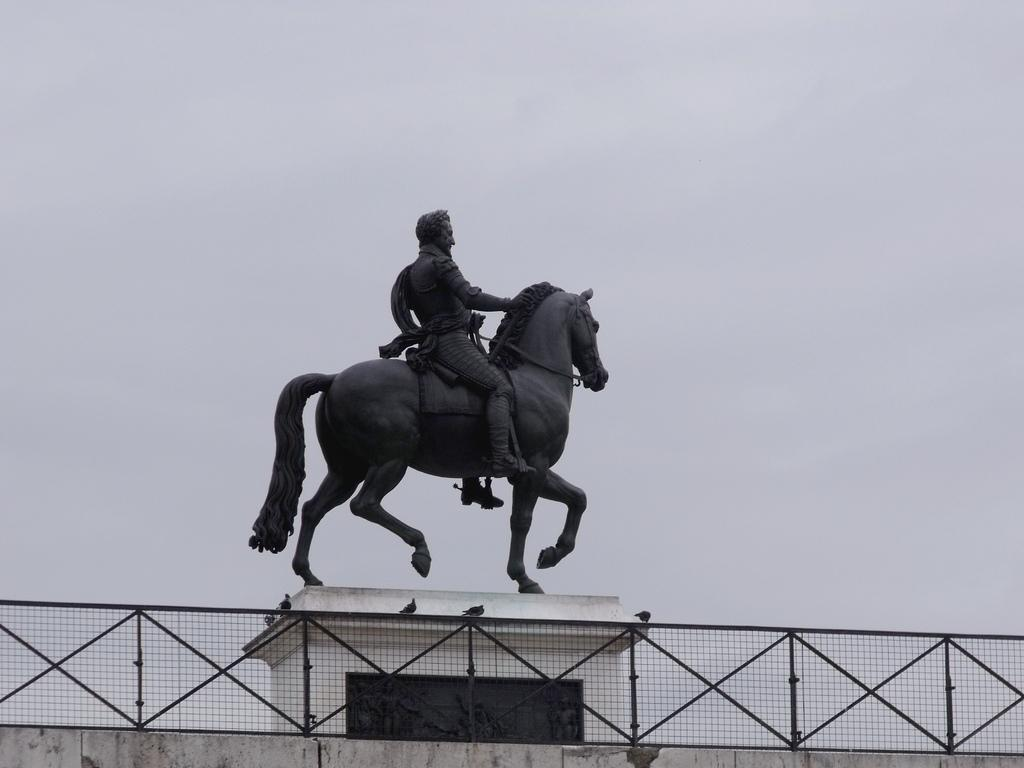What is depicted in the sculpture in the image? The sculpture in the image is of a person and a horse. What else can be seen in the image besides the sculpture? Fencing is visible in the image. What song is being sung by the person in the sculpture? There is no indication in the image that the person in the sculpture is singing a song. 